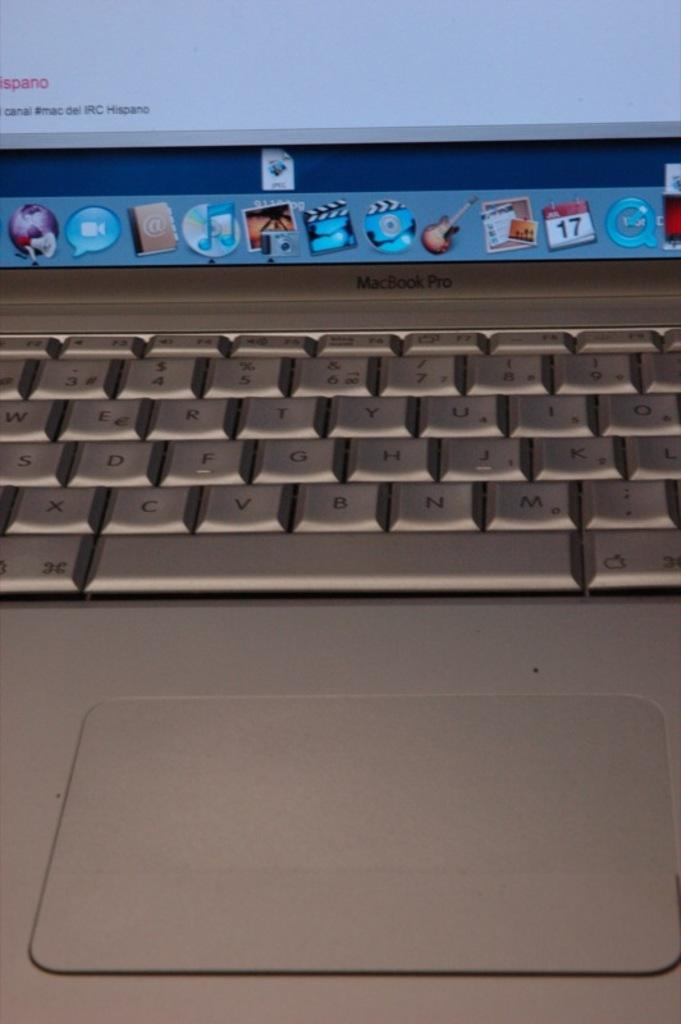Provide a one-sentence caption for the provided image. A MacBook Pro lap top computer keyboard and icon display. 